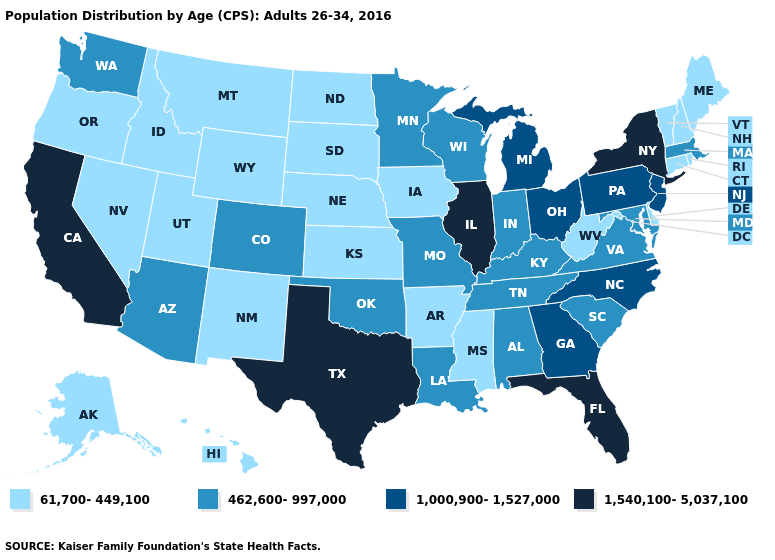Which states have the lowest value in the USA?
Keep it brief. Alaska, Arkansas, Connecticut, Delaware, Hawaii, Idaho, Iowa, Kansas, Maine, Mississippi, Montana, Nebraska, Nevada, New Hampshire, New Mexico, North Dakota, Oregon, Rhode Island, South Dakota, Utah, Vermont, West Virginia, Wyoming. Does the first symbol in the legend represent the smallest category?
Quick response, please. Yes. Does Idaho have a lower value than Ohio?
Give a very brief answer. Yes. Among the states that border Rhode Island , which have the highest value?
Be succinct. Massachusetts. What is the highest value in the MidWest ?
Give a very brief answer. 1,540,100-5,037,100. Does the first symbol in the legend represent the smallest category?
Keep it brief. Yes. Which states have the highest value in the USA?
Give a very brief answer. California, Florida, Illinois, New York, Texas. Does Missouri have the highest value in the USA?
Short answer required. No. What is the value of Alabama?
Write a very short answer. 462,600-997,000. What is the value of Wyoming?
Write a very short answer. 61,700-449,100. Which states have the lowest value in the USA?
Answer briefly. Alaska, Arkansas, Connecticut, Delaware, Hawaii, Idaho, Iowa, Kansas, Maine, Mississippi, Montana, Nebraska, Nevada, New Hampshire, New Mexico, North Dakota, Oregon, Rhode Island, South Dakota, Utah, Vermont, West Virginia, Wyoming. Does Nevada have the lowest value in the USA?
Quick response, please. Yes. Name the states that have a value in the range 1,000,900-1,527,000?
Give a very brief answer. Georgia, Michigan, New Jersey, North Carolina, Ohio, Pennsylvania. Does Iowa have a lower value than Tennessee?
Concise answer only. Yes. 